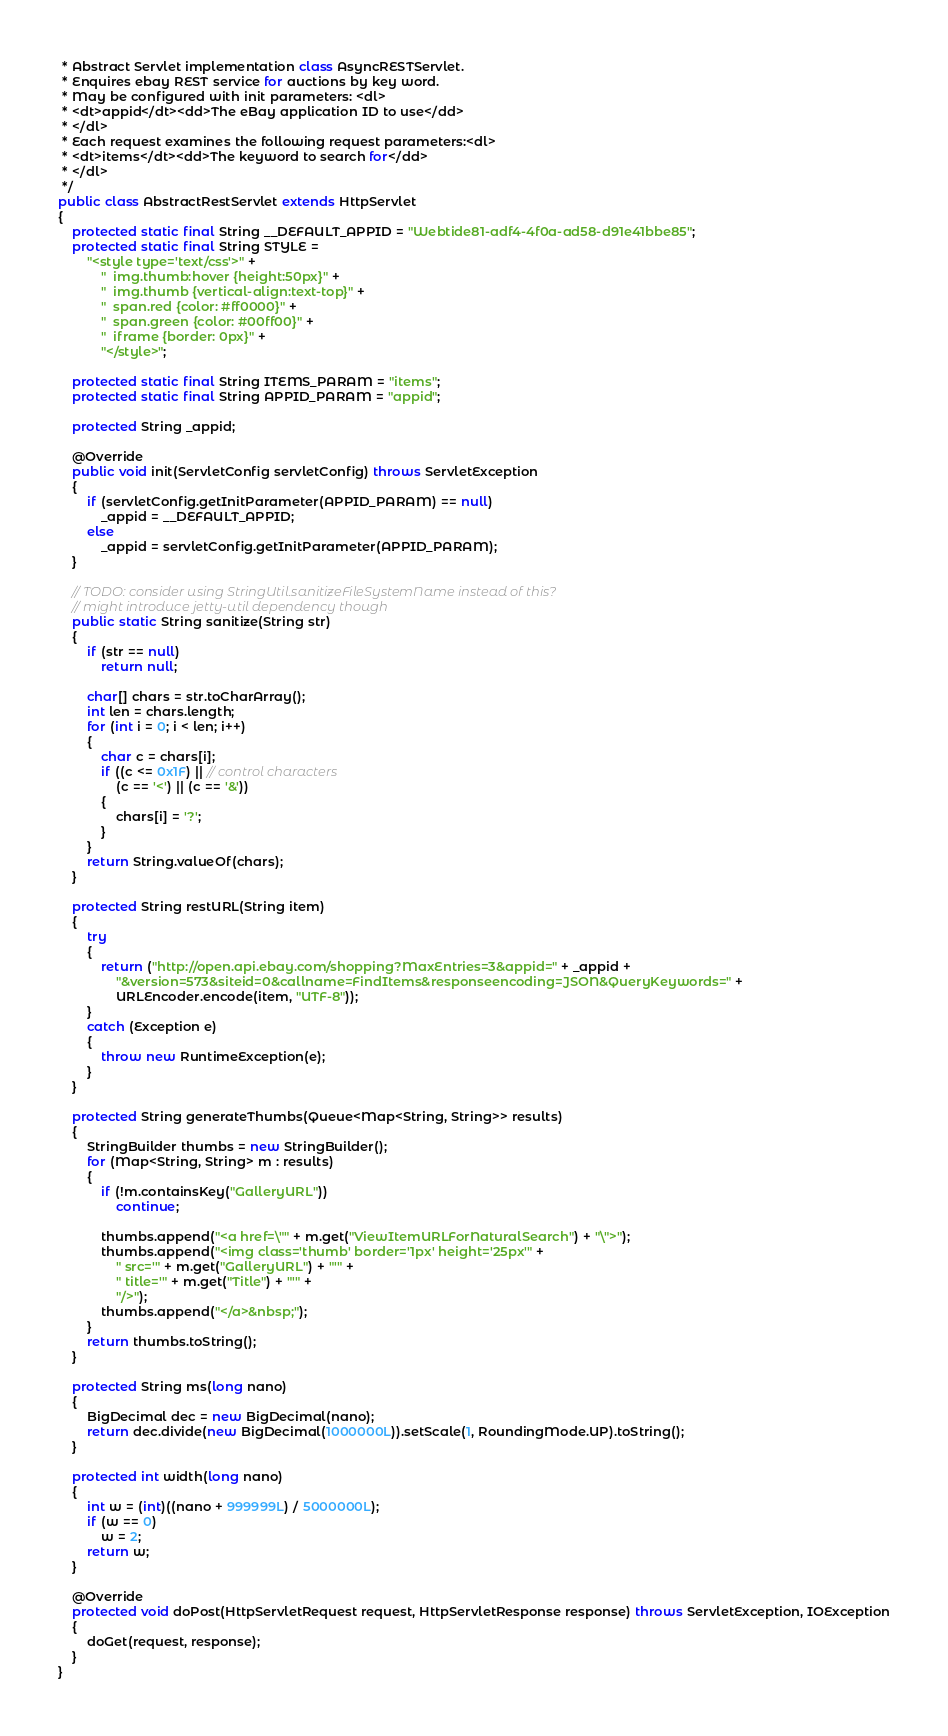<code> <loc_0><loc_0><loc_500><loc_500><_Java_> * Abstract Servlet implementation class AsyncRESTServlet.
 * Enquires ebay REST service for auctions by key word.
 * May be configured with init parameters: <dl>
 * <dt>appid</dt><dd>The eBay application ID to use</dd>
 * </dl>
 * Each request examines the following request parameters:<dl>
 * <dt>items</dt><dd>The keyword to search for</dd>
 * </dl>
 */
public class AbstractRestServlet extends HttpServlet
{
    protected static final String __DEFAULT_APPID = "Webtide81-adf4-4f0a-ad58-d91e41bbe85";
    protected static final String STYLE =
        "<style type='text/css'>" +
            "  img.thumb:hover {height:50px}" +
            "  img.thumb {vertical-align:text-top}" +
            "  span.red {color: #ff0000}" +
            "  span.green {color: #00ff00}" +
            "  iframe {border: 0px}" +
            "</style>";

    protected static final String ITEMS_PARAM = "items";
    protected static final String APPID_PARAM = "appid";

    protected String _appid;

    @Override
    public void init(ServletConfig servletConfig) throws ServletException
    {
        if (servletConfig.getInitParameter(APPID_PARAM) == null)
            _appid = __DEFAULT_APPID;
        else
            _appid = servletConfig.getInitParameter(APPID_PARAM);
    }

    // TODO: consider using StringUtil.sanitizeFileSystemName instead of this?
    // might introduce jetty-util dependency though
    public static String sanitize(String str)
    {
        if (str == null)
            return null;

        char[] chars = str.toCharArray();
        int len = chars.length;
        for (int i = 0; i < len; i++)
        {
            char c = chars[i];
            if ((c <= 0x1F) || // control characters
                (c == '<') || (c == '&'))
            {
                chars[i] = '?';
            }
        }
        return String.valueOf(chars);
    }

    protected String restURL(String item)
    {
        try
        {
            return ("http://open.api.ebay.com/shopping?MaxEntries=3&appid=" + _appid +
                "&version=573&siteid=0&callname=FindItems&responseencoding=JSON&QueryKeywords=" +
                URLEncoder.encode(item, "UTF-8"));
        }
        catch (Exception e)
        {
            throw new RuntimeException(e);
        }
    }

    protected String generateThumbs(Queue<Map<String, String>> results)
    {
        StringBuilder thumbs = new StringBuilder();
        for (Map<String, String> m : results)
        {
            if (!m.containsKey("GalleryURL"))
                continue;

            thumbs.append("<a href=\"" + m.get("ViewItemURLForNaturalSearch") + "\">");
            thumbs.append("<img class='thumb' border='1px' height='25px'" +
                " src='" + m.get("GalleryURL") + "'" +
                " title='" + m.get("Title") + "'" +
                "/>");
            thumbs.append("</a>&nbsp;");
        }
        return thumbs.toString();
    }

    protected String ms(long nano)
    {
        BigDecimal dec = new BigDecimal(nano);
        return dec.divide(new BigDecimal(1000000L)).setScale(1, RoundingMode.UP).toString();
    }

    protected int width(long nano)
    {
        int w = (int)((nano + 999999L) / 5000000L);
        if (w == 0)
            w = 2;
        return w;
    }

    @Override
    protected void doPost(HttpServletRequest request, HttpServletResponse response) throws ServletException, IOException
    {
        doGet(request, response);
    }
}
</code> 